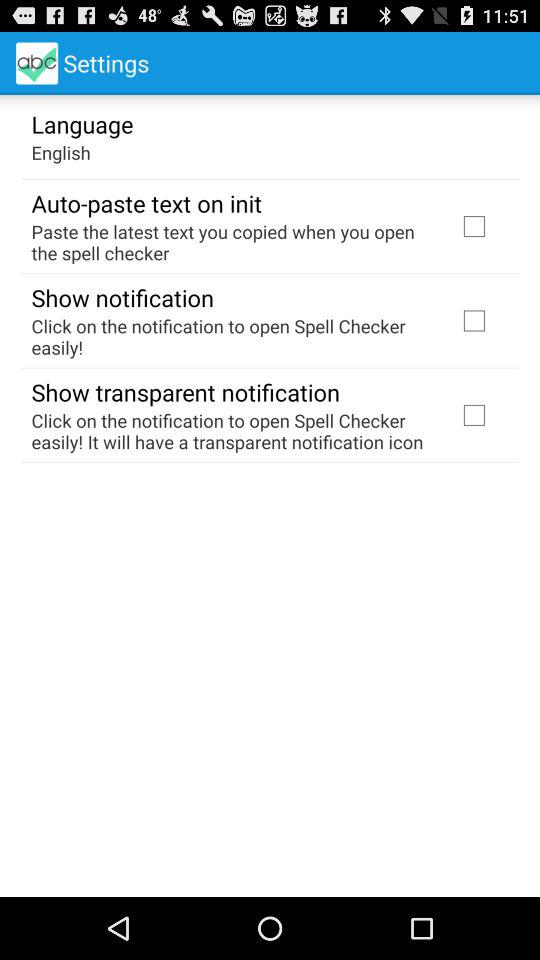What language is selected? The language is "English". 